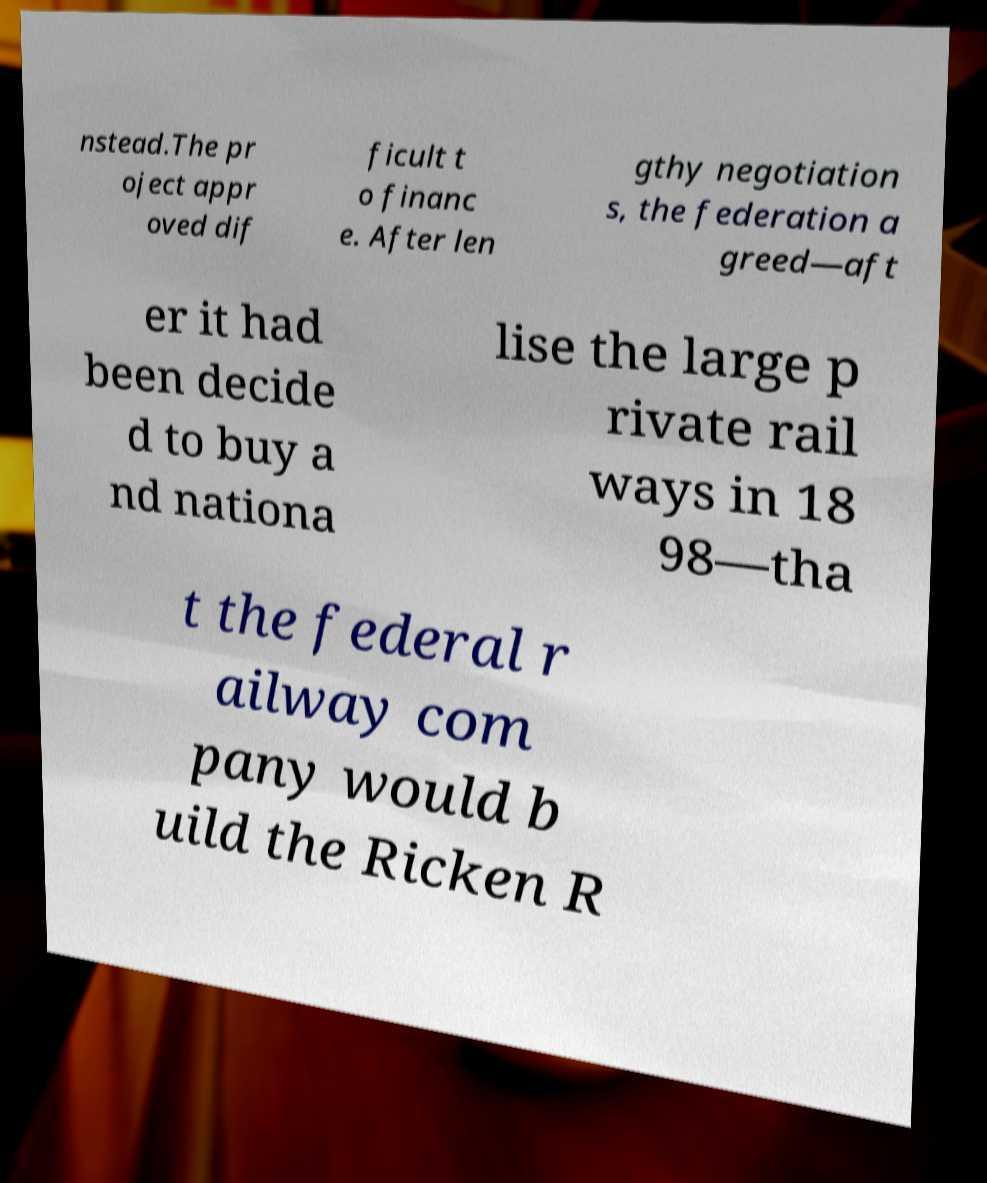Could you assist in decoding the text presented in this image and type it out clearly? nstead.The pr oject appr oved dif ficult t o financ e. After len gthy negotiation s, the federation a greed—aft er it had been decide d to buy a nd nationa lise the large p rivate rail ways in 18 98—tha t the federal r ailway com pany would b uild the Ricken R 